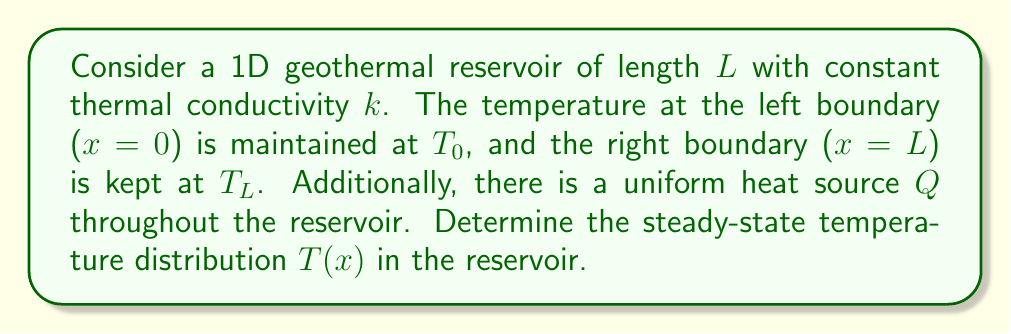Can you answer this question? To solve this problem, we'll use the 1D steady-state heat equation with a source term:

1) The governing equation is:
   $$k\frac{d^2T}{dx^2} + Q = 0$$

2) The boundary conditions are:
   $T(0) = T_0$ and $T(L) = T_L$

3) Integrate the equation once:
   $$k\frac{dT}{dx} = -Qx + C_1$$

4) Integrate again:
   $$kT = -\frac{1}{2}Qx^2 + C_1x + C_2$$

5) Solve for T:
   $$T(x) = -\frac{Q}{2k}x^2 + \frac{C_1}{k}x + \frac{C_2}{k}$$

6) Apply the boundary conditions:
   At $x = 0$: $T_0 = \frac{C_2}{k}$
   At $x = L$: $T_L = -\frac{Q}{2k}L^2 + \frac{C_1}{k}L + T_0$

7) Solve for $C_1$:
   $$C_1 = \frac{T_L - T_0}{L} + \frac{QL}{2}$$

8) Substitute back into the general solution:
   $$T(x) = -\frac{Q}{2k}x^2 + (\frac{T_L - T_0}{kL} + \frac{QL}{2k})x + T_0$$

9) Simplify:
   $$T(x) = \frac{T_L - T_0}{L}x + T_0 + \frac{Q}{2k}x(L-x)$$

This is the steady-state temperature distribution in the reservoir.
Answer: $T(x) = \frac{T_L - T_0}{L}x + T_0 + \frac{Q}{2k}x(L-x)$ 